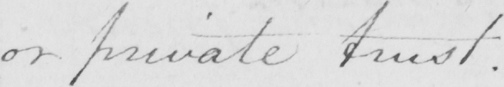Can you tell me what this handwritten text says? or private trust . 